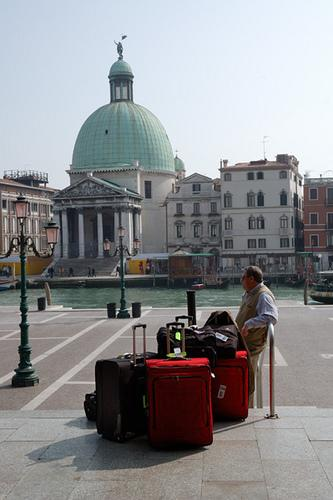What is this man enjoying here? Please explain your reasoning. vacation. He is on a vacation with all his luggage. 